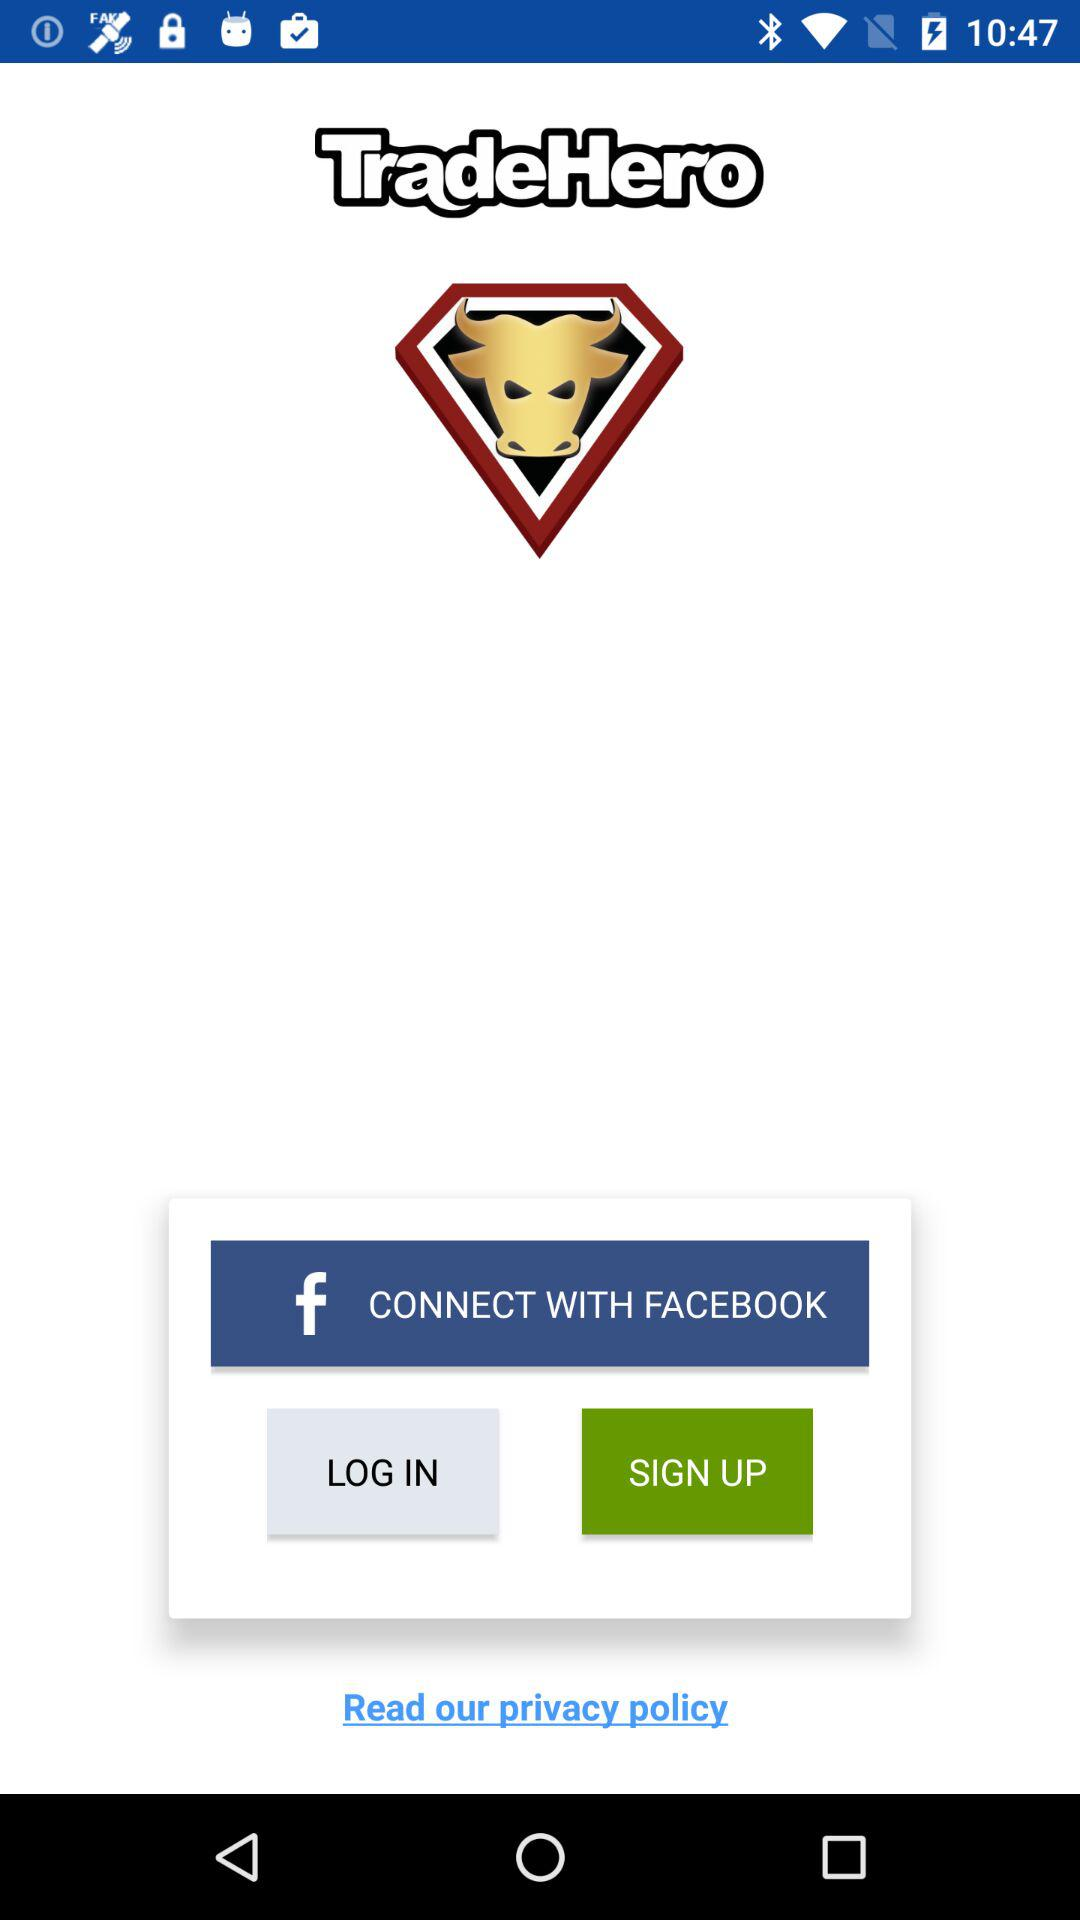What is the user's name?
When the provided information is insufficient, respond with <no answer>. <no answer> 